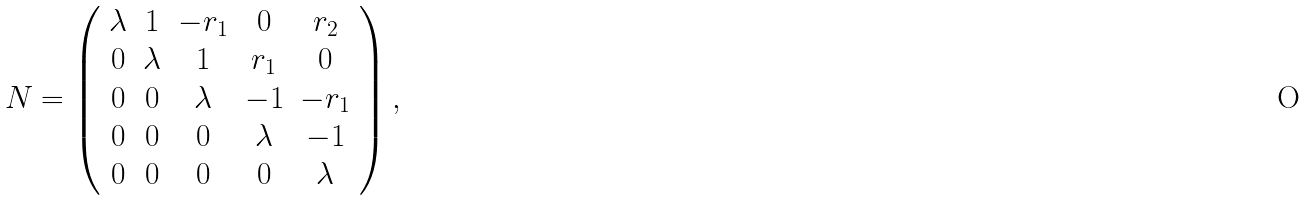Convert formula to latex. <formula><loc_0><loc_0><loc_500><loc_500>N = \left ( \begin{array} { c c c c c } \lambda & 1 & - r _ { 1 } & 0 & r _ { 2 } \\ 0 & \lambda & 1 & r _ { 1 } & 0 \\ 0 & 0 & \lambda & - 1 & - r _ { 1 } \\ 0 & 0 & 0 & \lambda & - 1 \\ 0 & 0 & 0 & 0 & \lambda \end{array} \right ) ,</formula> 